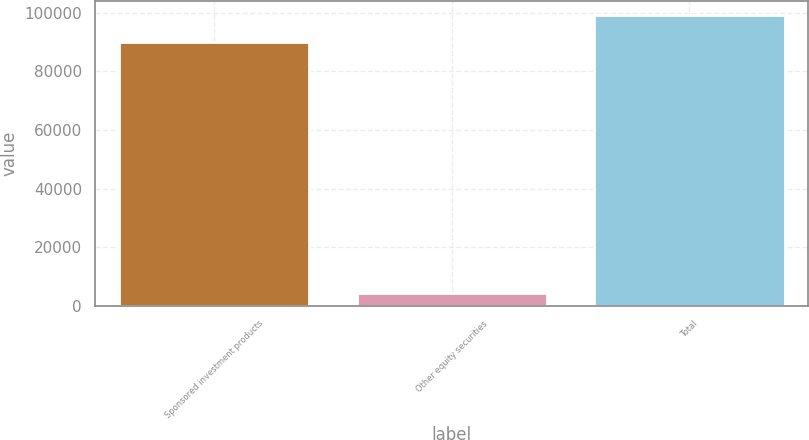Convert chart. <chart><loc_0><loc_0><loc_500><loc_500><bar_chart><fcel>Sponsored investment products<fcel>Other equity securities<fcel>Total<nl><fcel>90210<fcel>4200<fcel>99231<nl></chart> 